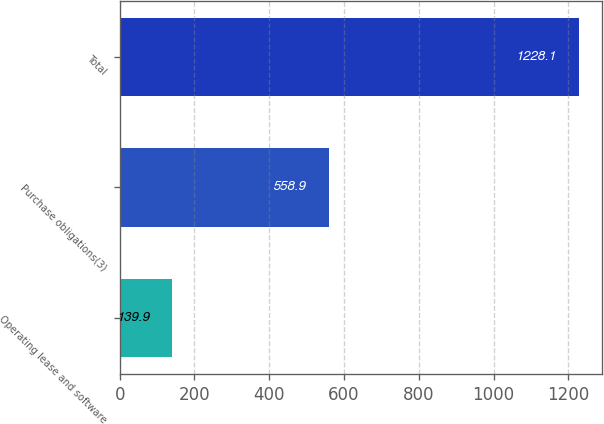Convert chart to OTSL. <chart><loc_0><loc_0><loc_500><loc_500><bar_chart><fcel>Operating lease and software<fcel>Purchase obligations(3)<fcel>Total<nl><fcel>139.9<fcel>558.9<fcel>1228.1<nl></chart> 